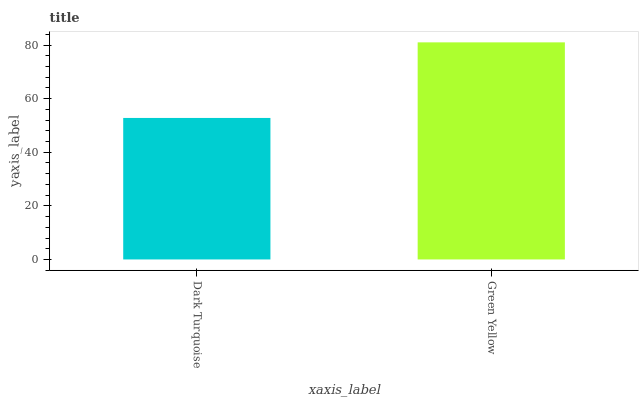Is Dark Turquoise the minimum?
Answer yes or no. Yes. Is Green Yellow the maximum?
Answer yes or no. Yes. Is Green Yellow the minimum?
Answer yes or no. No. Is Green Yellow greater than Dark Turquoise?
Answer yes or no. Yes. Is Dark Turquoise less than Green Yellow?
Answer yes or no. Yes. Is Dark Turquoise greater than Green Yellow?
Answer yes or no. No. Is Green Yellow less than Dark Turquoise?
Answer yes or no. No. Is Green Yellow the high median?
Answer yes or no. Yes. Is Dark Turquoise the low median?
Answer yes or no. Yes. Is Dark Turquoise the high median?
Answer yes or no. No. Is Green Yellow the low median?
Answer yes or no. No. 